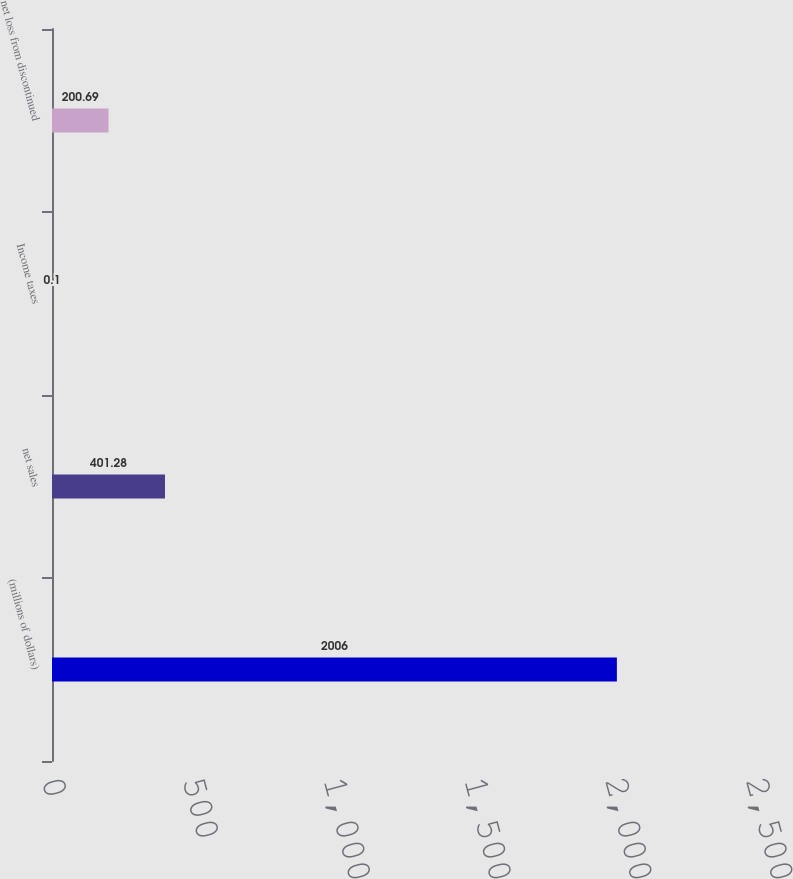Convert chart. <chart><loc_0><loc_0><loc_500><loc_500><bar_chart><fcel>(millions of dollars)<fcel>net sales<fcel>Income taxes<fcel>net loss from discontinued<nl><fcel>2006<fcel>401.28<fcel>0.1<fcel>200.69<nl></chart> 